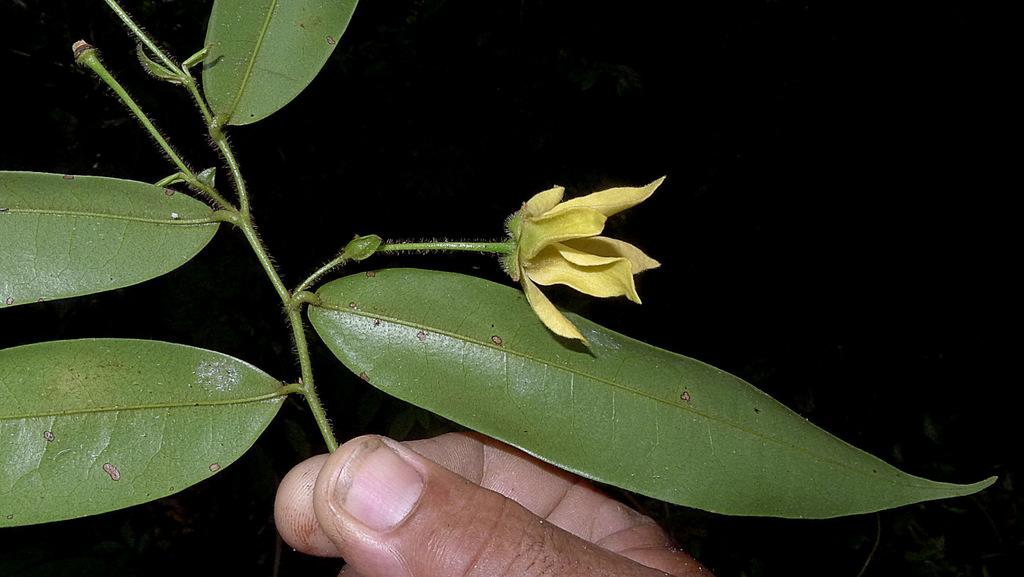What type of plant material is present in the image? There are leaves in the image. What part of a human body can be seen at the bottom of the image? There is a human hand at the bottom of the image. What type of plant is depicted in the image? There is a flower in the image. What type of pipe is being used by the person's brother in the image? There is no person or brother present in the image, and therefore no pipe can be observed. 